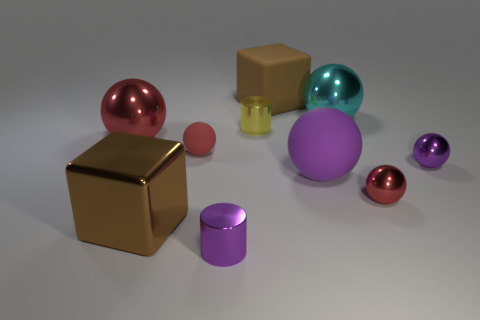Subtract all purple blocks. How many red spheres are left? 3 Subtract 2 balls. How many balls are left? 4 Subtract all cyan spheres. How many spheres are left? 5 Subtract all cyan metal balls. How many balls are left? 5 Subtract all gray spheres. Subtract all blue blocks. How many spheres are left? 6 Subtract all blocks. How many objects are left? 8 Subtract 0 blue balls. How many objects are left? 10 Subtract all big purple rubber balls. Subtract all metal cylinders. How many objects are left? 7 Add 6 small purple objects. How many small purple objects are left? 8 Add 4 tiny purple things. How many tiny purple things exist? 6 